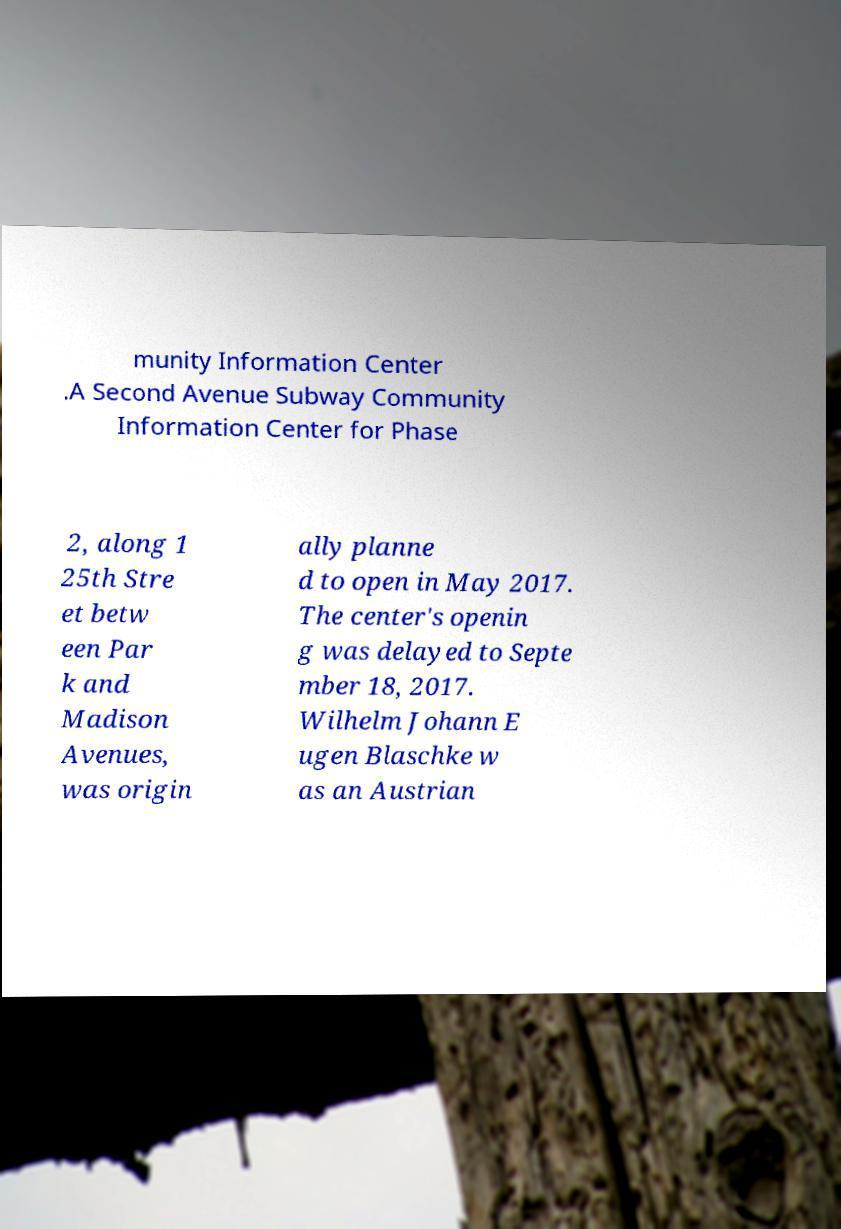Please read and relay the text visible in this image. What does it say? munity Information Center .A Second Avenue Subway Community Information Center for Phase 2, along 1 25th Stre et betw een Par k and Madison Avenues, was origin ally planne d to open in May 2017. The center's openin g was delayed to Septe mber 18, 2017. Wilhelm Johann E ugen Blaschke w as an Austrian 